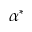<formula> <loc_0><loc_0><loc_500><loc_500>\alpha ^ { * }</formula> 